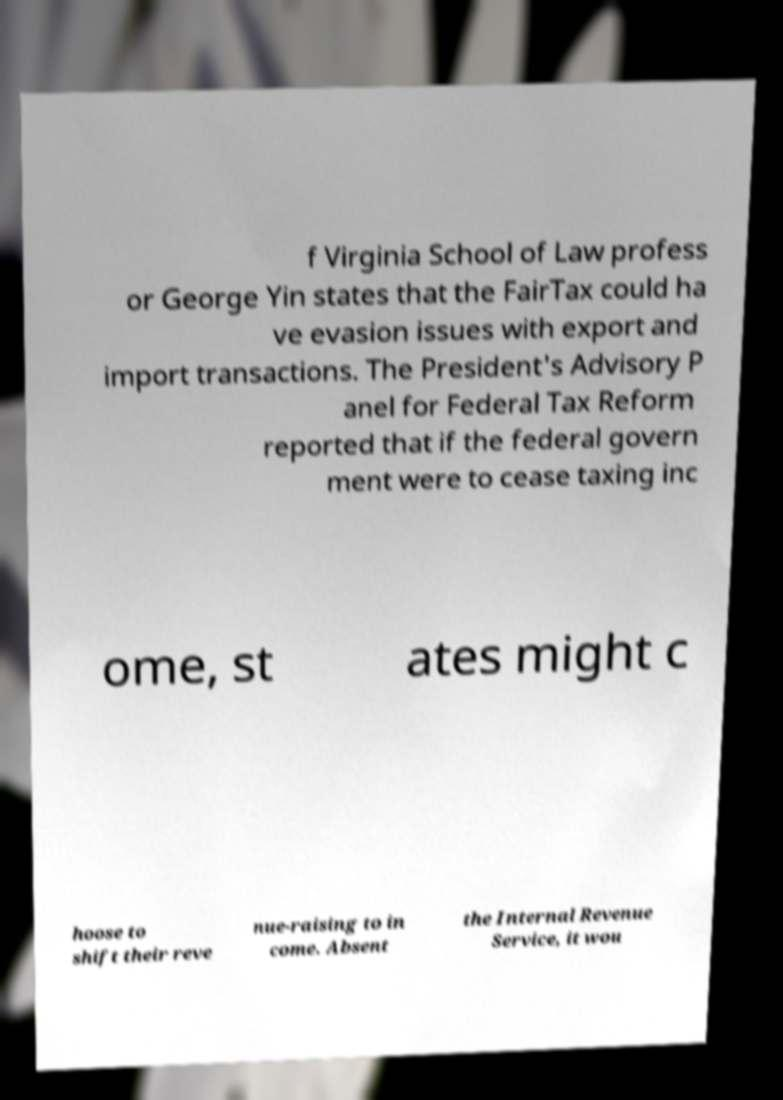Please identify and transcribe the text found in this image. f Virginia School of Law profess or George Yin states that the FairTax could ha ve evasion issues with export and import transactions. The President's Advisory P anel for Federal Tax Reform reported that if the federal govern ment were to cease taxing inc ome, st ates might c hoose to shift their reve nue-raising to in come. Absent the Internal Revenue Service, it wou 